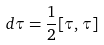<formula> <loc_0><loc_0><loc_500><loc_500>d \tau = \frac { 1 } { 2 } [ \tau , \tau ]</formula> 